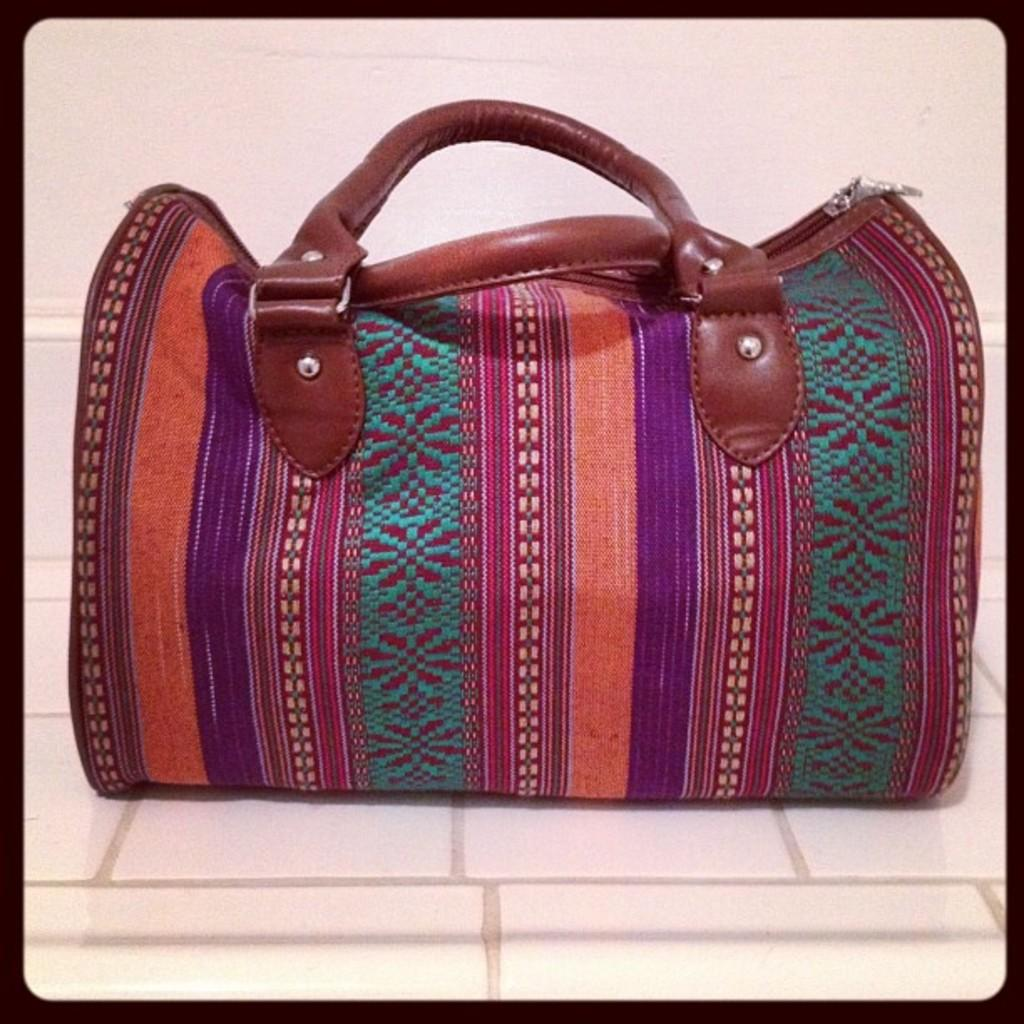What type of accessory is featured in the image? There is a colorful handbag in the image. Can you describe the handbags come in various colors and designs? Yes, handbags can come in various colors and designs, as seen in the image. What might the handbag be used for? The handbag might be used for carrying personal items, such as a wallet, phone, or keys. Can you see any toes in the image? No, there are no toes visible in the image; it features a colorful handbag. What type of drink is being served in the handbag? There is no drink present in the image; it only features a colorful handbag. 